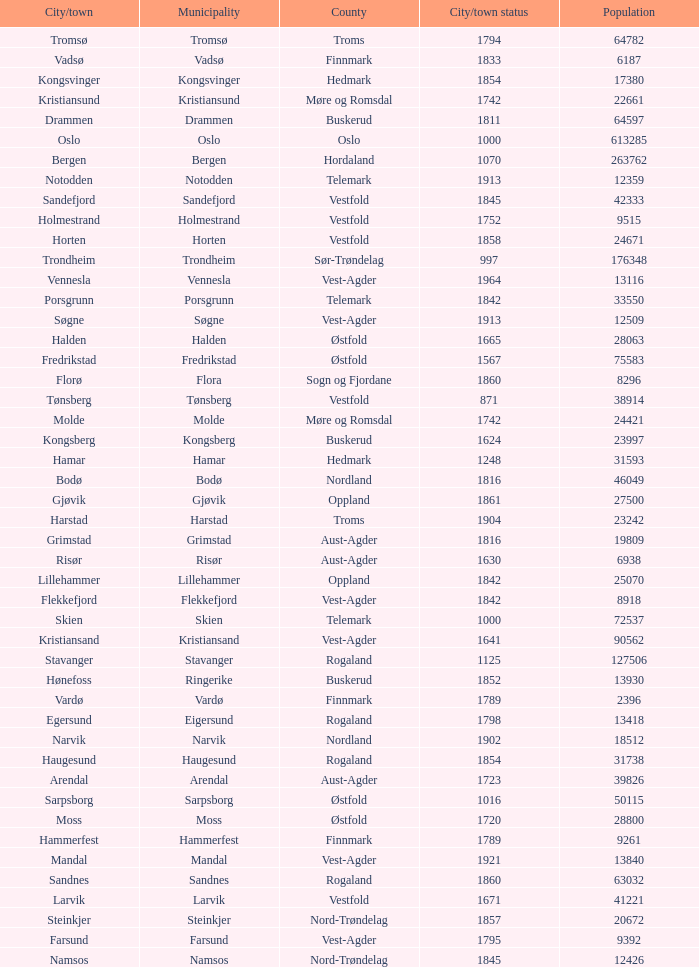What are the cities/towns located in the municipality of Moss? Moss. 